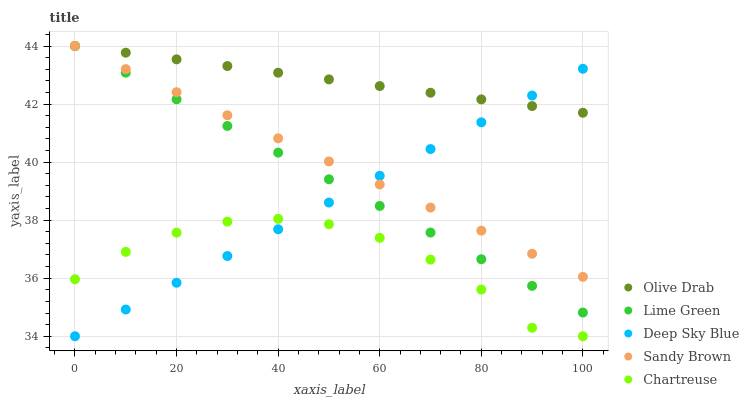Does Chartreuse have the minimum area under the curve?
Answer yes or no. Yes. Does Olive Drab have the maximum area under the curve?
Answer yes or no. Yes. Does Lime Green have the minimum area under the curve?
Answer yes or no. No. Does Lime Green have the maximum area under the curve?
Answer yes or no. No. Is Sandy Brown the smoothest?
Answer yes or no. Yes. Is Chartreuse the roughest?
Answer yes or no. Yes. Is Lime Green the smoothest?
Answer yes or no. No. Is Lime Green the roughest?
Answer yes or no. No. Does Chartreuse have the lowest value?
Answer yes or no. Yes. Does Lime Green have the lowest value?
Answer yes or no. No. Does Olive Drab have the highest value?
Answer yes or no. Yes. Does Chartreuse have the highest value?
Answer yes or no. No. Is Chartreuse less than Sandy Brown?
Answer yes or no. Yes. Is Olive Drab greater than Chartreuse?
Answer yes or no. Yes. Does Deep Sky Blue intersect Sandy Brown?
Answer yes or no. Yes. Is Deep Sky Blue less than Sandy Brown?
Answer yes or no. No. Is Deep Sky Blue greater than Sandy Brown?
Answer yes or no. No. Does Chartreuse intersect Sandy Brown?
Answer yes or no. No. 